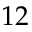Convert formula to latex. <formula><loc_0><loc_0><loc_500><loc_500>1 2</formula> 